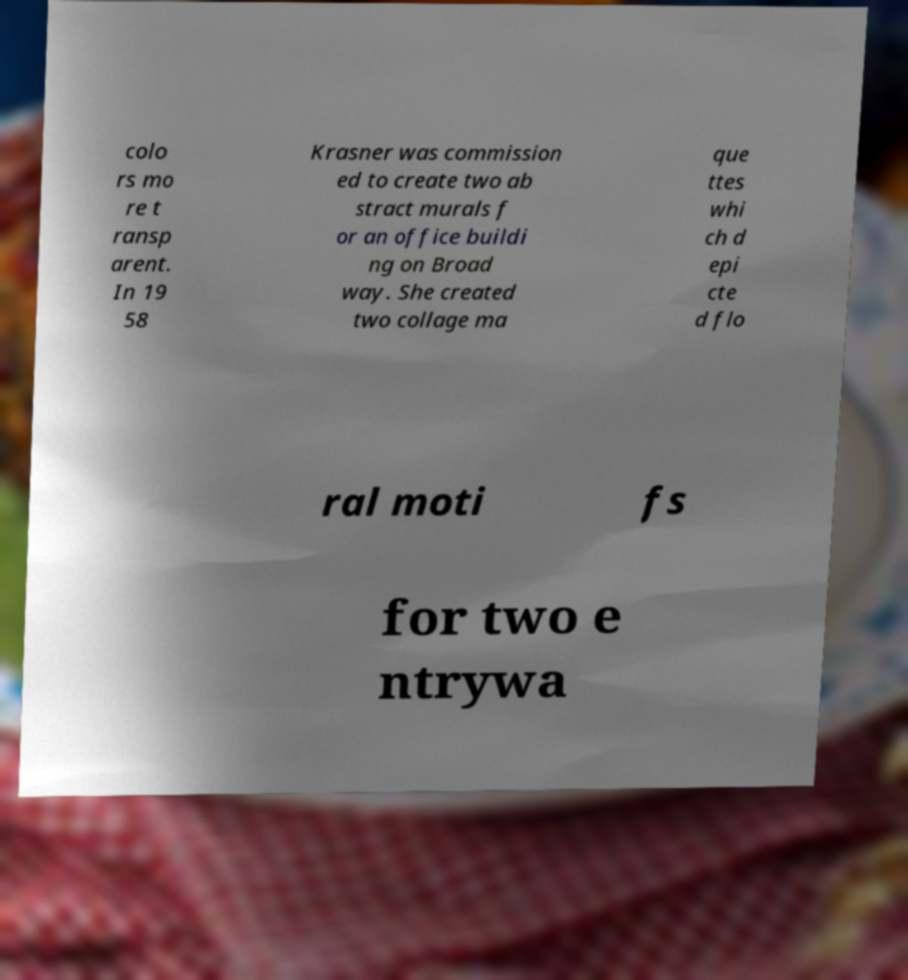What messages or text are displayed in this image? I need them in a readable, typed format. colo rs mo re t ransp arent. In 19 58 Krasner was commission ed to create two ab stract murals f or an office buildi ng on Broad way. She created two collage ma que ttes whi ch d epi cte d flo ral moti fs for two e ntrywa 